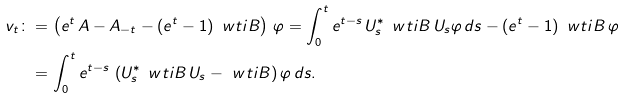Convert formula to latex. <formula><loc_0><loc_0><loc_500><loc_500>v _ { t } \colon & = \left ( e ^ { t } \, A - A _ { - t } - ( e ^ { t } - 1 ) \, \ w t i { B } \right ) \, \varphi = \int _ { 0 } ^ { t } e ^ { t - s } \, U _ { s } ^ { * } \, \ w t i { B } \, U _ { s } \varphi \, d s - ( e ^ { t } - 1 ) \, \ w t i { B } \, \varphi \\ & = \int _ { 0 } ^ { t } e ^ { t - s } \, \left ( U _ { s } ^ { * } \, \ w t i { B } \, U _ { s } - \ w t i { B } \right ) \varphi \, d s .</formula> 